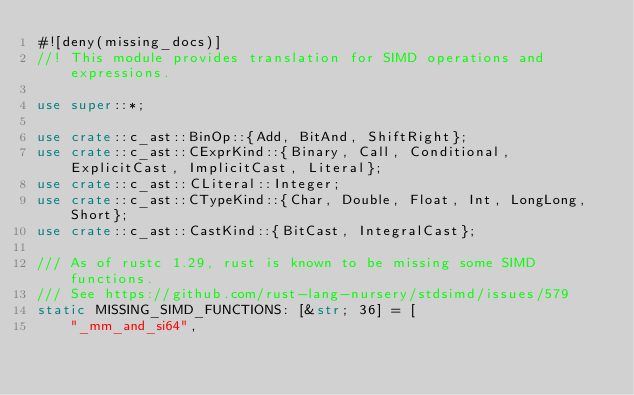<code> <loc_0><loc_0><loc_500><loc_500><_Rust_>#![deny(missing_docs)]
//! This module provides translation for SIMD operations and expressions.

use super::*;

use crate::c_ast::BinOp::{Add, BitAnd, ShiftRight};
use crate::c_ast::CExprKind::{Binary, Call, Conditional, ExplicitCast, ImplicitCast, Literal};
use crate::c_ast::CLiteral::Integer;
use crate::c_ast::CTypeKind::{Char, Double, Float, Int, LongLong, Short};
use crate::c_ast::CastKind::{BitCast, IntegralCast};

/// As of rustc 1.29, rust is known to be missing some SIMD functions.
/// See https://github.com/rust-lang-nursery/stdsimd/issues/579
static MISSING_SIMD_FUNCTIONS: [&str; 36] = [
    "_mm_and_si64",</code> 